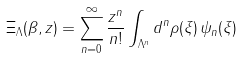<formula> <loc_0><loc_0><loc_500><loc_500>\Xi _ { \Lambda } ( \beta , z ) = \sum _ { n = 0 } ^ { \infty } \frac { z ^ { n } } { n ! } \int _ { \Lambda ^ { n } } d ^ { n } \rho ( \xi ) \, \psi _ { n } ( \xi )</formula> 